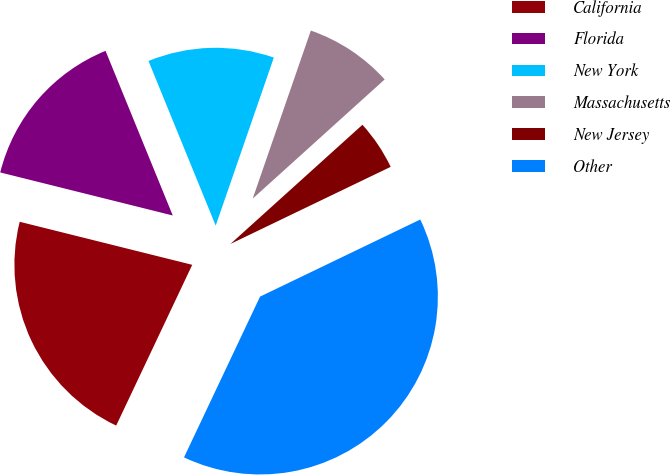<chart> <loc_0><loc_0><loc_500><loc_500><pie_chart><fcel>California<fcel>Florida<fcel>New York<fcel>Massachusetts<fcel>New Jersey<fcel>Other<nl><fcel>21.86%<fcel>14.94%<fcel>11.47%<fcel>8.01%<fcel>4.55%<fcel>39.17%<nl></chart> 